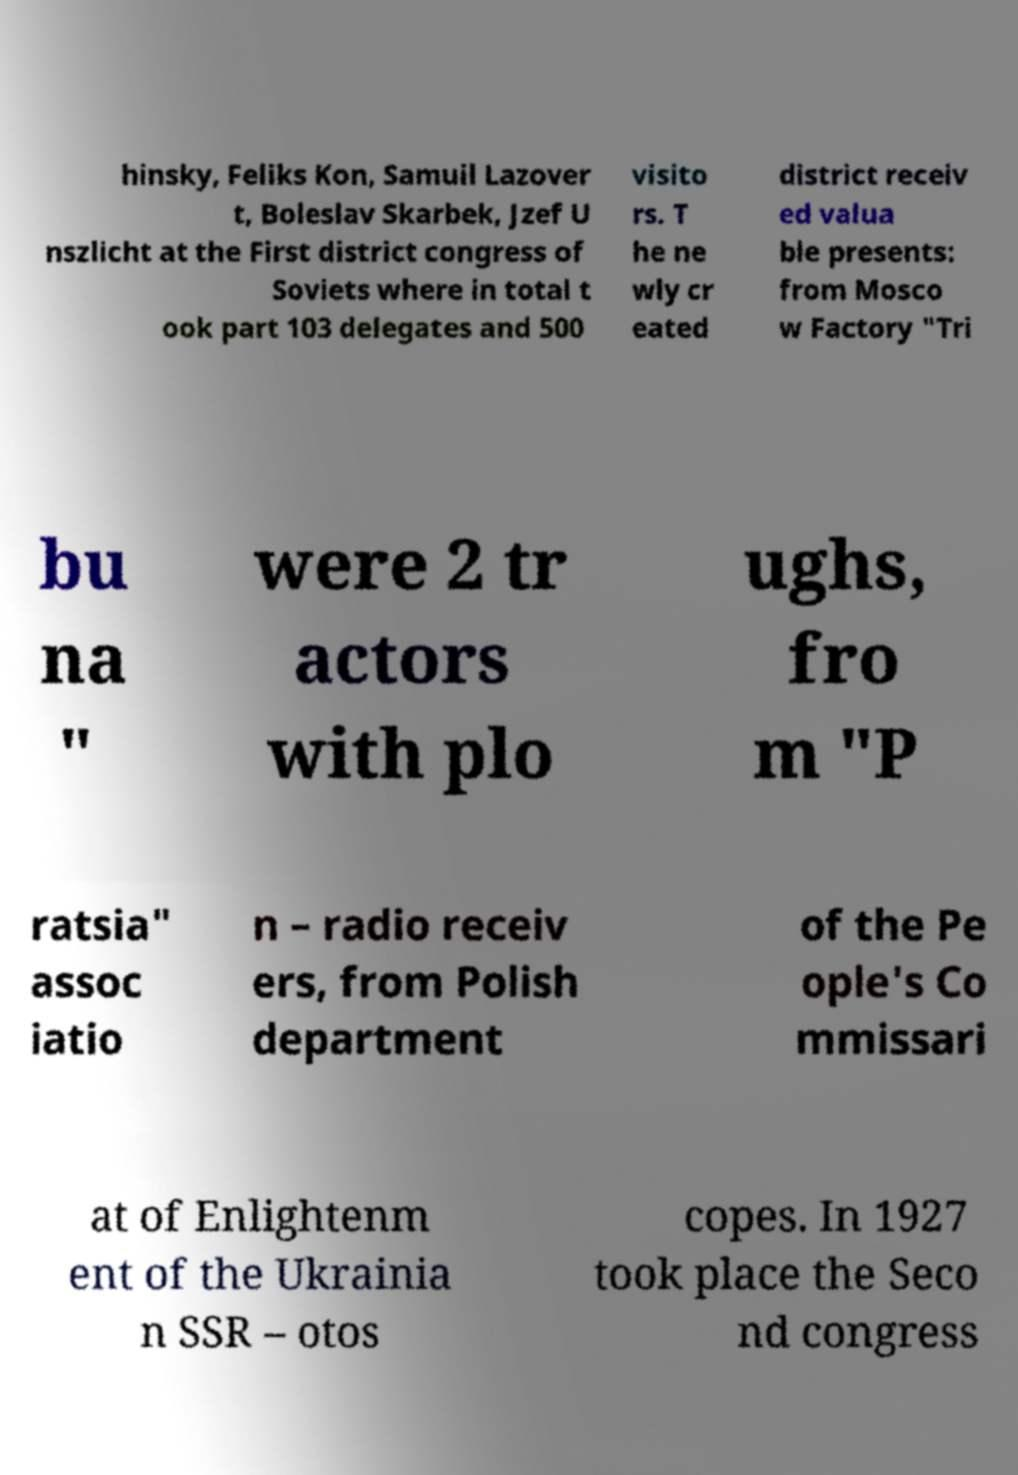There's text embedded in this image that I need extracted. Can you transcribe it verbatim? hinsky, Feliks Kon, Samuil Lazover t, Boleslav Skarbek, Jzef U nszlicht at the First district congress of Soviets where in total t ook part 103 delegates and 500 visito rs. T he ne wly cr eated district receiv ed valua ble presents: from Mosco w Factory "Tri bu na " were 2 tr actors with plo ughs, fro m "P ratsia" assoc iatio n – radio receiv ers, from Polish department of the Pe ople's Co mmissari at of Enlightenm ent of the Ukrainia n SSR – otos copes. In 1927 took place the Seco nd congress 